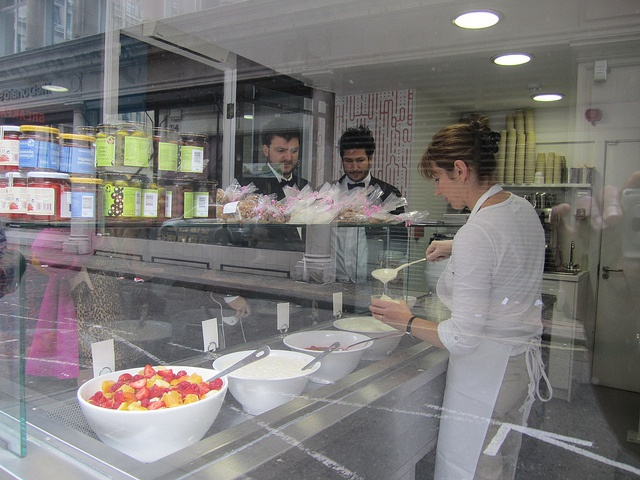Describe the objects in this image and their specific colors. I can see people in gray, darkgray, and black tones, bowl in gray, lightgray, salmon, orange, and darkgray tones, bowl in gray, lightgray, and darkgray tones, people in gray, black, and darkgray tones, and cup in gray, olive, darkgreen, and black tones in this image. 